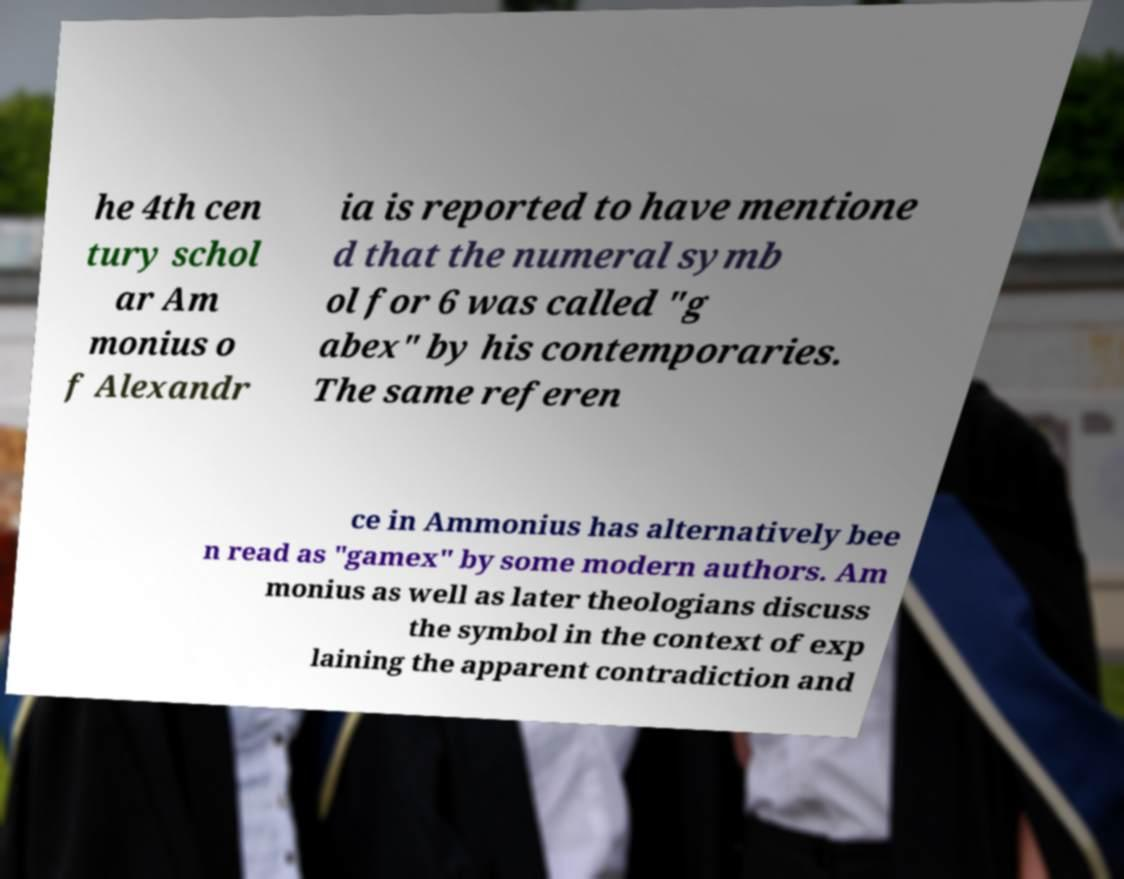I need the written content from this picture converted into text. Can you do that? he 4th cen tury schol ar Am monius o f Alexandr ia is reported to have mentione d that the numeral symb ol for 6 was called "g abex" by his contemporaries. The same referen ce in Ammonius has alternatively bee n read as "gamex" by some modern authors. Am monius as well as later theologians discuss the symbol in the context of exp laining the apparent contradiction and 